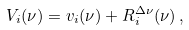Convert formula to latex. <formula><loc_0><loc_0><loc_500><loc_500>V _ { i } ( \nu ) = v _ { i } ( \nu ) + R _ { i } ^ { \Delta \nu } ( \nu ) \, ,</formula> 